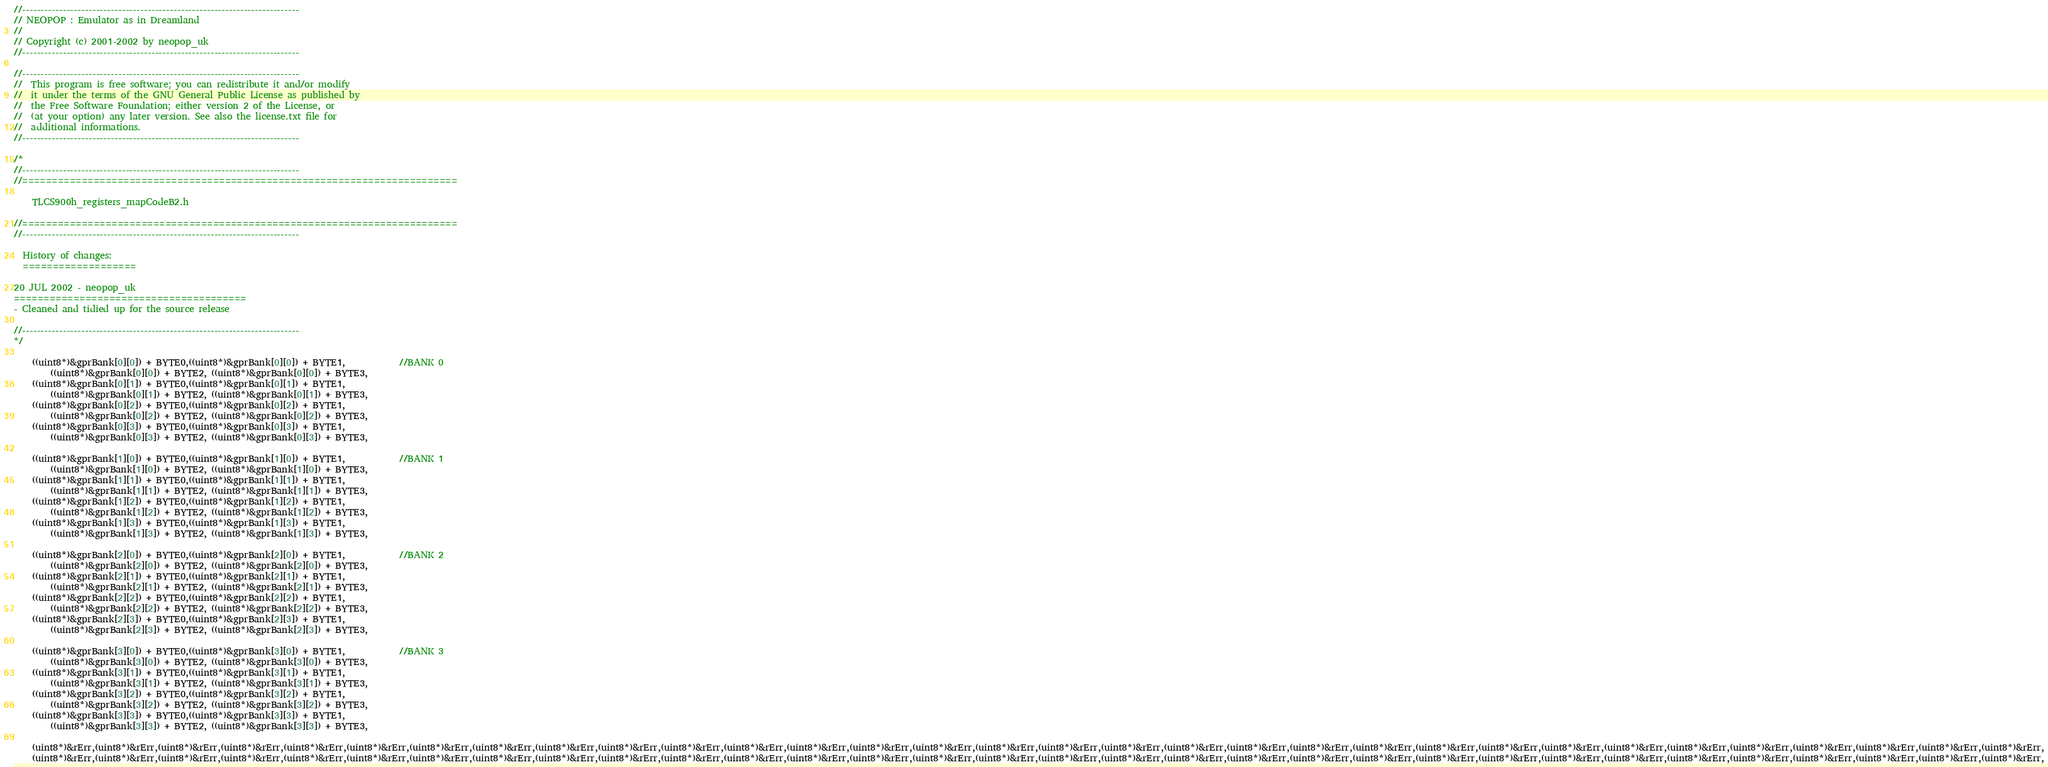Convert code to text. <code><loc_0><loc_0><loc_500><loc_500><_C_>//---------------------------------------------------------------------------
// NEOPOP : Emulator as in Dreamland
//
// Copyright (c) 2001-2002 by neopop_uk
//---------------------------------------------------------------------------

//---------------------------------------------------------------------------
//	This program is free software; you can redistribute it and/or modify
//	it under the terms of the GNU General Public License as published by
//	the Free Software Foundation; either version 2 of the License, or
//	(at your option) any later version. See also the license.txt file for
//	additional informations.
//---------------------------------------------------------------------------

/*
//---------------------------------------------------------------------------
//=========================================================================

	TLCS900h_registers_mapCodeB2.h

//=========================================================================
//---------------------------------------------------------------------------

  History of changes:
  ===================

20 JUL 2002 - neopop_uk
=======================================
- Cleaned and tidied up for the source release

//---------------------------------------------------------------------------
*/

	((uint8*)&gprBank[0][0]) + BYTE0,((uint8*)&gprBank[0][0]) + BYTE1,			//BANK 0
		((uint8*)&gprBank[0][0]) + BYTE2, ((uint8*)&gprBank[0][0]) + BYTE3,
	((uint8*)&gprBank[0][1]) + BYTE0,((uint8*)&gprBank[0][1]) + BYTE1,
		((uint8*)&gprBank[0][1]) + BYTE2, ((uint8*)&gprBank[0][1]) + BYTE3,
	((uint8*)&gprBank[0][2]) + BYTE0,((uint8*)&gprBank[0][2]) + BYTE1,
		((uint8*)&gprBank[0][2]) + BYTE2, ((uint8*)&gprBank[0][2]) + BYTE3,
	((uint8*)&gprBank[0][3]) + BYTE0,((uint8*)&gprBank[0][3]) + BYTE1,
		((uint8*)&gprBank[0][3]) + BYTE2, ((uint8*)&gprBank[0][3]) + BYTE3,

	((uint8*)&gprBank[1][0]) + BYTE0,((uint8*)&gprBank[1][0]) + BYTE1,			//BANK 1
		((uint8*)&gprBank[1][0]) + BYTE2, ((uint8*)&gprBank[1][0]) + BYTE3,
	((uint8*)&gprBank[1][1]) + BYTE0,((uint8*)&gprBank[1][1]) + BYTE1,
		((uint8*)&gprBank[1][1]) + BYTE2, ((uint8*)&gprBank[1][1]) + BYTE3,
	((uint8*)&gprBank[1][2]) + BYTE0,((uint8*)&gprBank[1][2]) + BYTE1,
		((uint8*)&gprBank[1][2]) + BYTE2, ((uint8*)&gprBank[1][2]) + BYTE3,
	((uint8*)&gprBank[1][3]) + BYTE0,((uint8*)&gprBank[1][3]) + BYTE1,
		((uint8*)&gprBank[1][3]) + BYTE2, ((uint8*)&gprBank[1][3]) + BYTE3,

	((uint8*)&gprBank[2][0]) + BYTE0,((uint8*)&gprBank[2][0]) + BYTE1,			//BANK 2
		((uint8*)&gprBank[2][0]) + BYTE2, ((uint8*)&gprBank[2][0]) + BYTE3,
	((uint8*)&gprBank[2][1]) + BYTE0,((uint8*)&gprBank[2][1]) + BYTE1,
		((uint8*)&gprBank[2][1]) + BYTE2, ((uint8*)&gprBank[2][1]) + BYTE3,
	((uint8*)&gprBank[2][2]) + BYTE0,((uint8*)&gprBank[2][2]) + BYTE1,
		((uint8*)&gprBank[2][2]) + BYTE2, ((uint8*)&gprBank[2][2]) + BYTE3,
	((uint8*)&gprBank[2][3]) + BYTE0,((uint8*)&gprBank[2][3]) + BYTE1,
		((uint8*)&gprBank[2][3]) + BYTE2, ((uint8*)&gprBank[2][3]) + BYTE3,

	((uint8*)&gprBank[3][0]) + BYTE0,((uint8*)&gprBank[3][0]) + BYTE1,			//BANK 3
		((uint8*)&gprBank[3][0]) + BYTE2, ((uint8*)&gprBank[3][0]) + BYTE3,
	((uint8*)&gprBank[3][1]) + BYTE0,((uint8*)&gprBank[3][1]) + BYTE1,
		((uint8*)&gprBank[3][1]) + BYTE2, ((uint8*)&gprBank[3][1]) + BYTE3,
	((uint8*)&gprBank[3][2]) + BYTE0,((uint8*)&gprBank[3][2]) + BYTE1,
		((uint8*)&gprBank[3][2]) + BYTE2, ((uint8*)&gprBank[3][2]) + BYTE3,
	((uint8*)&gprBank[3][3]) + BYTE0,((uint8*)&gprBank[3][3]) + BYTE1,
		((uint8*)&gprBank[3][3]) + BYTE2, ((uint8*)&gprBank[3][3]) + BYTE3,

	(uint8*)&rErr,(uint8*)&rErr,(uint8*)&rErr,(uint8*)&rErr,(uint8*)&rErr,(uint8*)&rErr,(uint8*)&rErr,(uint8*)&rErr,(uint8*)&rErr,(uint8*)&rErr,(uint8*)&rErr,(uint8*)&rErr,(uint8*)&rErr,(uint8*)&rErr,(uint8*)&rErr,(uint8*)&rErr,(uint8*)&rErr,(uint8*)&rErr,(uint8*)&rErr,(uint8*)&rErr,(uint8*)&rErr,(uint8*)&rErr,(uint8*)&rErr,(uint8*)&rErr,(uint8*)&rErr,(uint8*)&rErr,(uint8*)&rErr,(uint8*)&rErr,(uint8*)&rErr,(uint8*)&rErr,(uint8*)&rErr,(uint8*)&rErr,
	(uint8*)&rErr,(uint8*)&rErr,(uint8*)&rErr,(uint8*)&rErr,(uint8*)&rErr,(uint8*)&rErr,(uint8*)&rErr,(uint8*)&rErr,(uint8*)&rErr,(uint8*)&rErr,(uint8*)&rErr,(uint8*)&rErr,(uint8*)&rErr,(uint8*)&rErr,(uint8*)&rErr,(uint8*)&rErr,(uint8*)&rErr,(uint8*)&rErr,(uint8*)&rErr,(uint8*)&rErr,(uint8*)&rErr,(uint8*)&rErr,(uint8*)&rErr,(uint8*)&rErr,(uint8*)&rErr,(uint8*)&rErr,(uint8*)&rErr,(uint8*)&rErr,(uint8*)&rErr,(uint8*)&rErr,(uint8*)&rErr,(uint8*)&rErr,</code> 